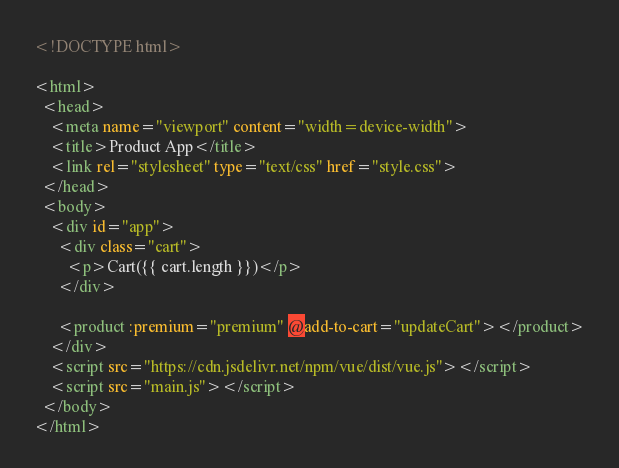<code> <loc_0><loc_0><loc_500><loc_500><_HTML_><!DOCTYPE html>

<html>
  <head>
    <meta name="viewport" content="width=device-width">
    <title>Product App</title>
    <link rel="stylesheet" type="text/css" href="style.css">
  </head> 
  <body>
    <div id="app">
      <div class="cart">
        <p>Cart({{ cart.length }})</p>
      </div>

      <product :premium="premium" @add-to-cart="updateCart"></product>
    </div>
    <script src="https://cdn.jsdelivr.net/npm/vue/dist/vue.js"></script>
    <script src="main.js"></script>
  </body>
</html></code> 